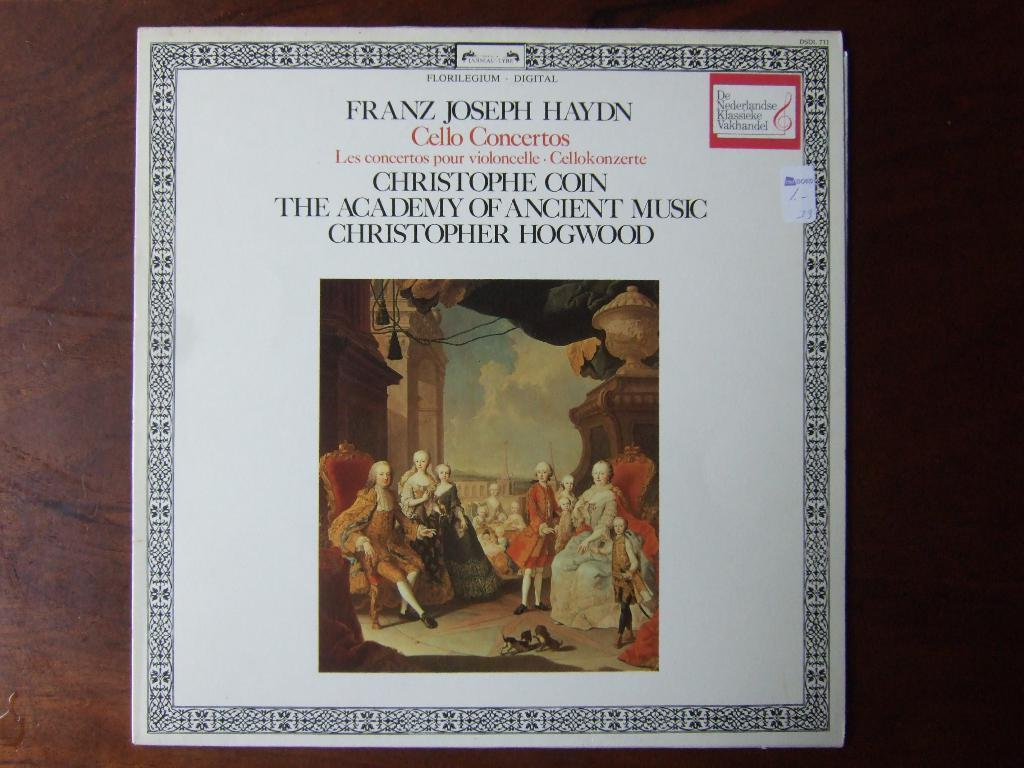<image>
Share a concise interpretation of the image provided. A record contains cello concertos by franz haydn. 